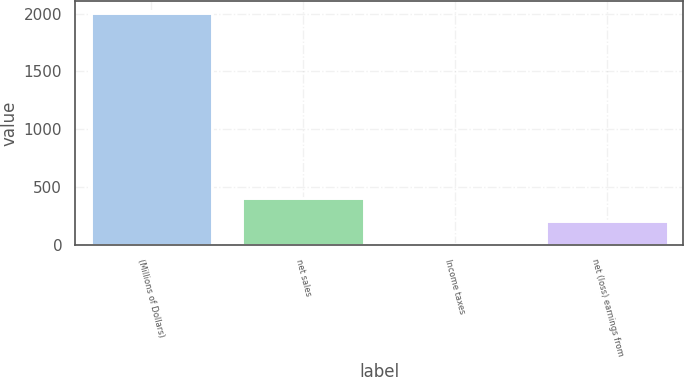Convert chart. <chart><loc_0><loc_0><loc_500><loc_500><bar_chart><fcel>(Millions of Dollars)<fcel>net sales<fcel>Income taxes<fcel>net (loss) earnings from<nl><fcel>2006<fcel>401.28<fcel>0.1<fcel>200.69<nl></chart> 